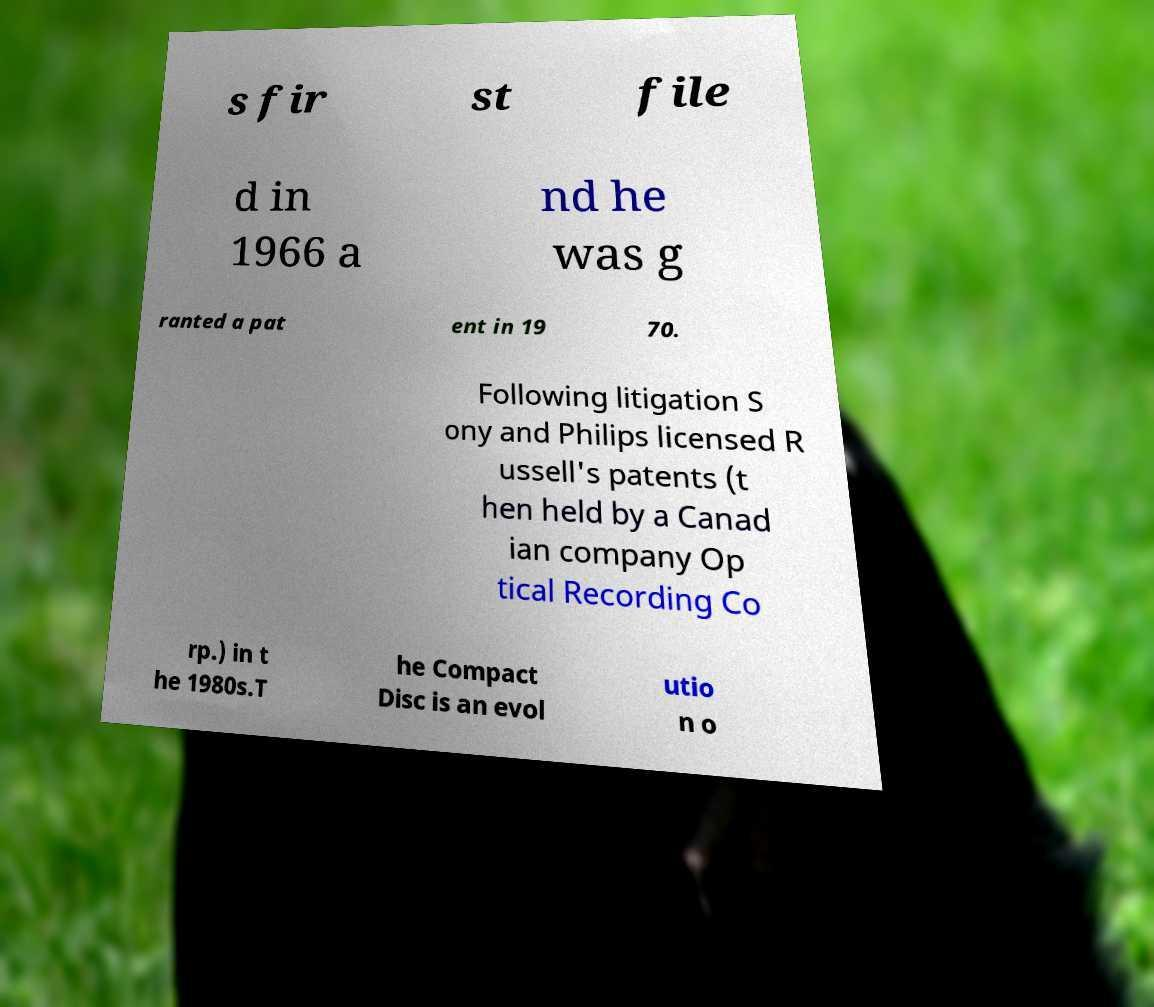Could you assist in decoding the text presented in this image and type it out clearly? s fir st file d in 1966 a nd he was g ranted a pat ent in 19 70. Following litigation S ony and Philips licensed R ussell's patents (t hen held by a Canad ian company Op tical Recording Co rp.) in t he 1980s.T he Compact Disc is an evol utio n o 